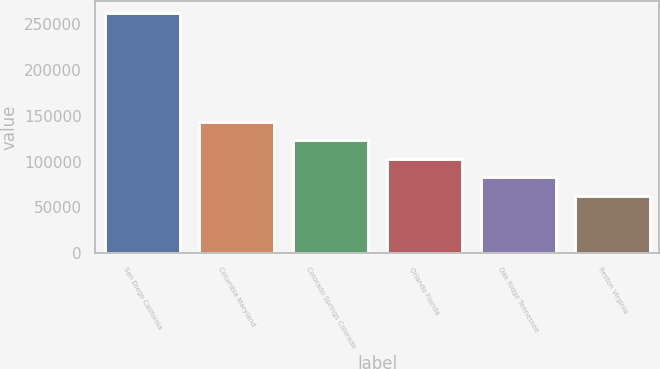Convert chart. <chart><loc_0><loc_0><loc_500><loc_500><bar_chart><fcel>San Diego California<fcel>Columbia Maryland<fcel>Colorado Springs Colorado<fcel>Orlando Florida<fcel>Oak Ridge Tennessee<fcel>Reston Virginia<nl><fcel>262000<fcel>143000<fcel>123000<fcel>103000<fcel>83000<fcel>62000<nl></chart> 